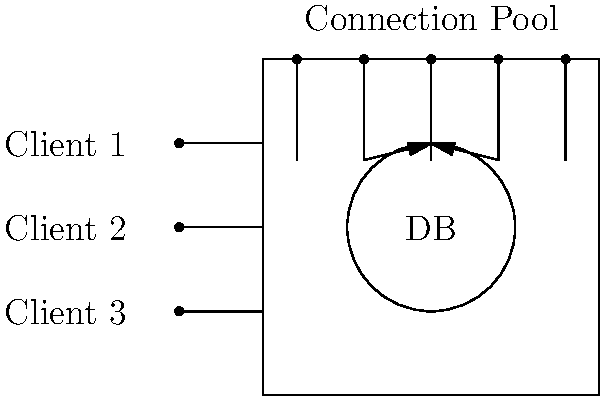In the diagram above, which represents a database connection pooling setup, how many available connections are shown in the connection pool, and why is this approach beneficial for a web application experiencing persistent database connection issues? To answer this question, let's analyze the diagram and understand the concept of database connection pooling:

1. The diagram shows a database (DB) at the bottom, a connection pool in the middle, and client connections on the left.

2. Within the connection pool, we can see 5 dots at the top, each representing an available database connection.

3. Database connection pooling is beneficial for web applications with persistent connection issues because:

   a) It reduces the overhead of creating new connections: Instead of establishing a new connection for each client request, connections are reused from the pool.
   
   b) It improves performance: Connection pooling minimizes the time spent in establishing database connections, which is especially important for applications with frequent, short-lived connections.
   
   c) It manages connection limits: By controlling the number of connections, it prevents overwhelming the database server with too many simultaneous connections.
   
   d) It enhances scalability: As the application grows, connection pooling helps manage resources more efficiently, allowing the application to handle more concurrent users.

4. In this specific diagram, we can see that out of the 5 available connections in the pool, 2 are currently being used (as indicated by the arrows), leaving 3 connections still available for future requests.

5. This setup allows the web application to handle multiple client requests efficiently, even if there are temporary connection issues, as clients can quickly obtain a connection from the pool instead of creating a new one each time.
Answer: 5 connections; improves performance, reduces overhead, manages resources efficiently 